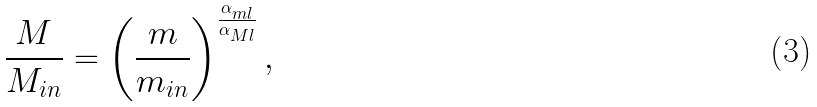Convert formula to latex. <formula><loc_0><loc_0><loc_500><loc_500>\frac { M } { M _ { i n } } = \left ( \frac { m } { m _ { i n } } \right ) ^ { \frac { \alpha _ { m l } } { \alpha _ { M l } } } ,</formula> 